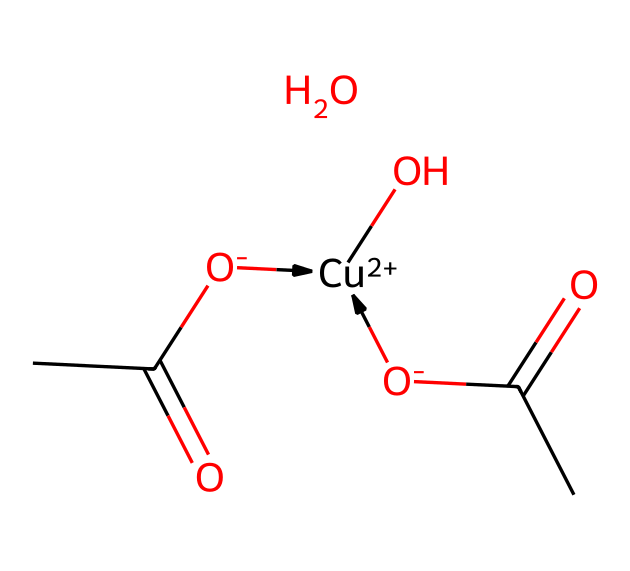What is the central metal ion in copper(II) acetate? The central metal ion is indicated by the notation [Cu+2], suggesting that Copper is present in a +2 oxidation state in the structure.
Answer: Copper How many acetate ligands coordinate to the central metal in copper(II) acetate? In the provided SMILES representation, there are two [O-]C(=O)C groups that correspond to acetate ligands, indicating that two ligands are coordinating to the central metal.
Answer: 2 What type of coordination geometry is observed in copper(II) acetate? The structure suggests a square planar or octahedral arrangement, often observed in coordination compounds with a d9 configuration like Cu(II).
Answer: Square planar What is the oxidation state of copper in copper(II) acetate? The oxidation state of copper is indicated by the notation [Cu+2], showing that it is in the +2 oxidation state.
Answer: +2 How many oxygen atoms are present in the copper(II) acetate structure? The chemical representation shows 4 oxygen atoms: two from each acetate ligand and one from the hydroxyl group on copper.
Answer: 4 Does copper(II) acetate possess any acidic or basic properties? The presence of the acetate anions and the hydroxyl group implies that copper(II) acetate can act as a weak acid in solution.
Answer: Weak acid 